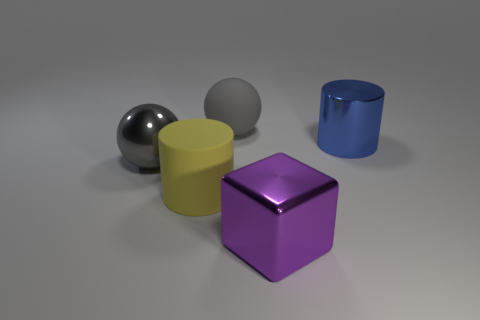Add 1 big brown rubber cubes. How many objects exist? 6 Subtract all cylinders. How many objects are left? 3 Subtract 0 green balls. How many objects are left? 5 Subtract all small red matte cylinders. Subtract all blue cylinders. How many objects are left? 4 Add 4 metallic blocks. How many metallic blocks are left? 5 Add 4 big red metal objects. How many big red metal objects exist? 4 